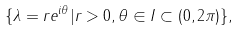Convert formula to latex. <formula><loc_0><loc_0><loc_500><loc_500>\{ \lambda = r e ^ { i \theta } | r > 0 , \theta \in I \subset ( 0 , 2 \pi ) \} ,</formula> 